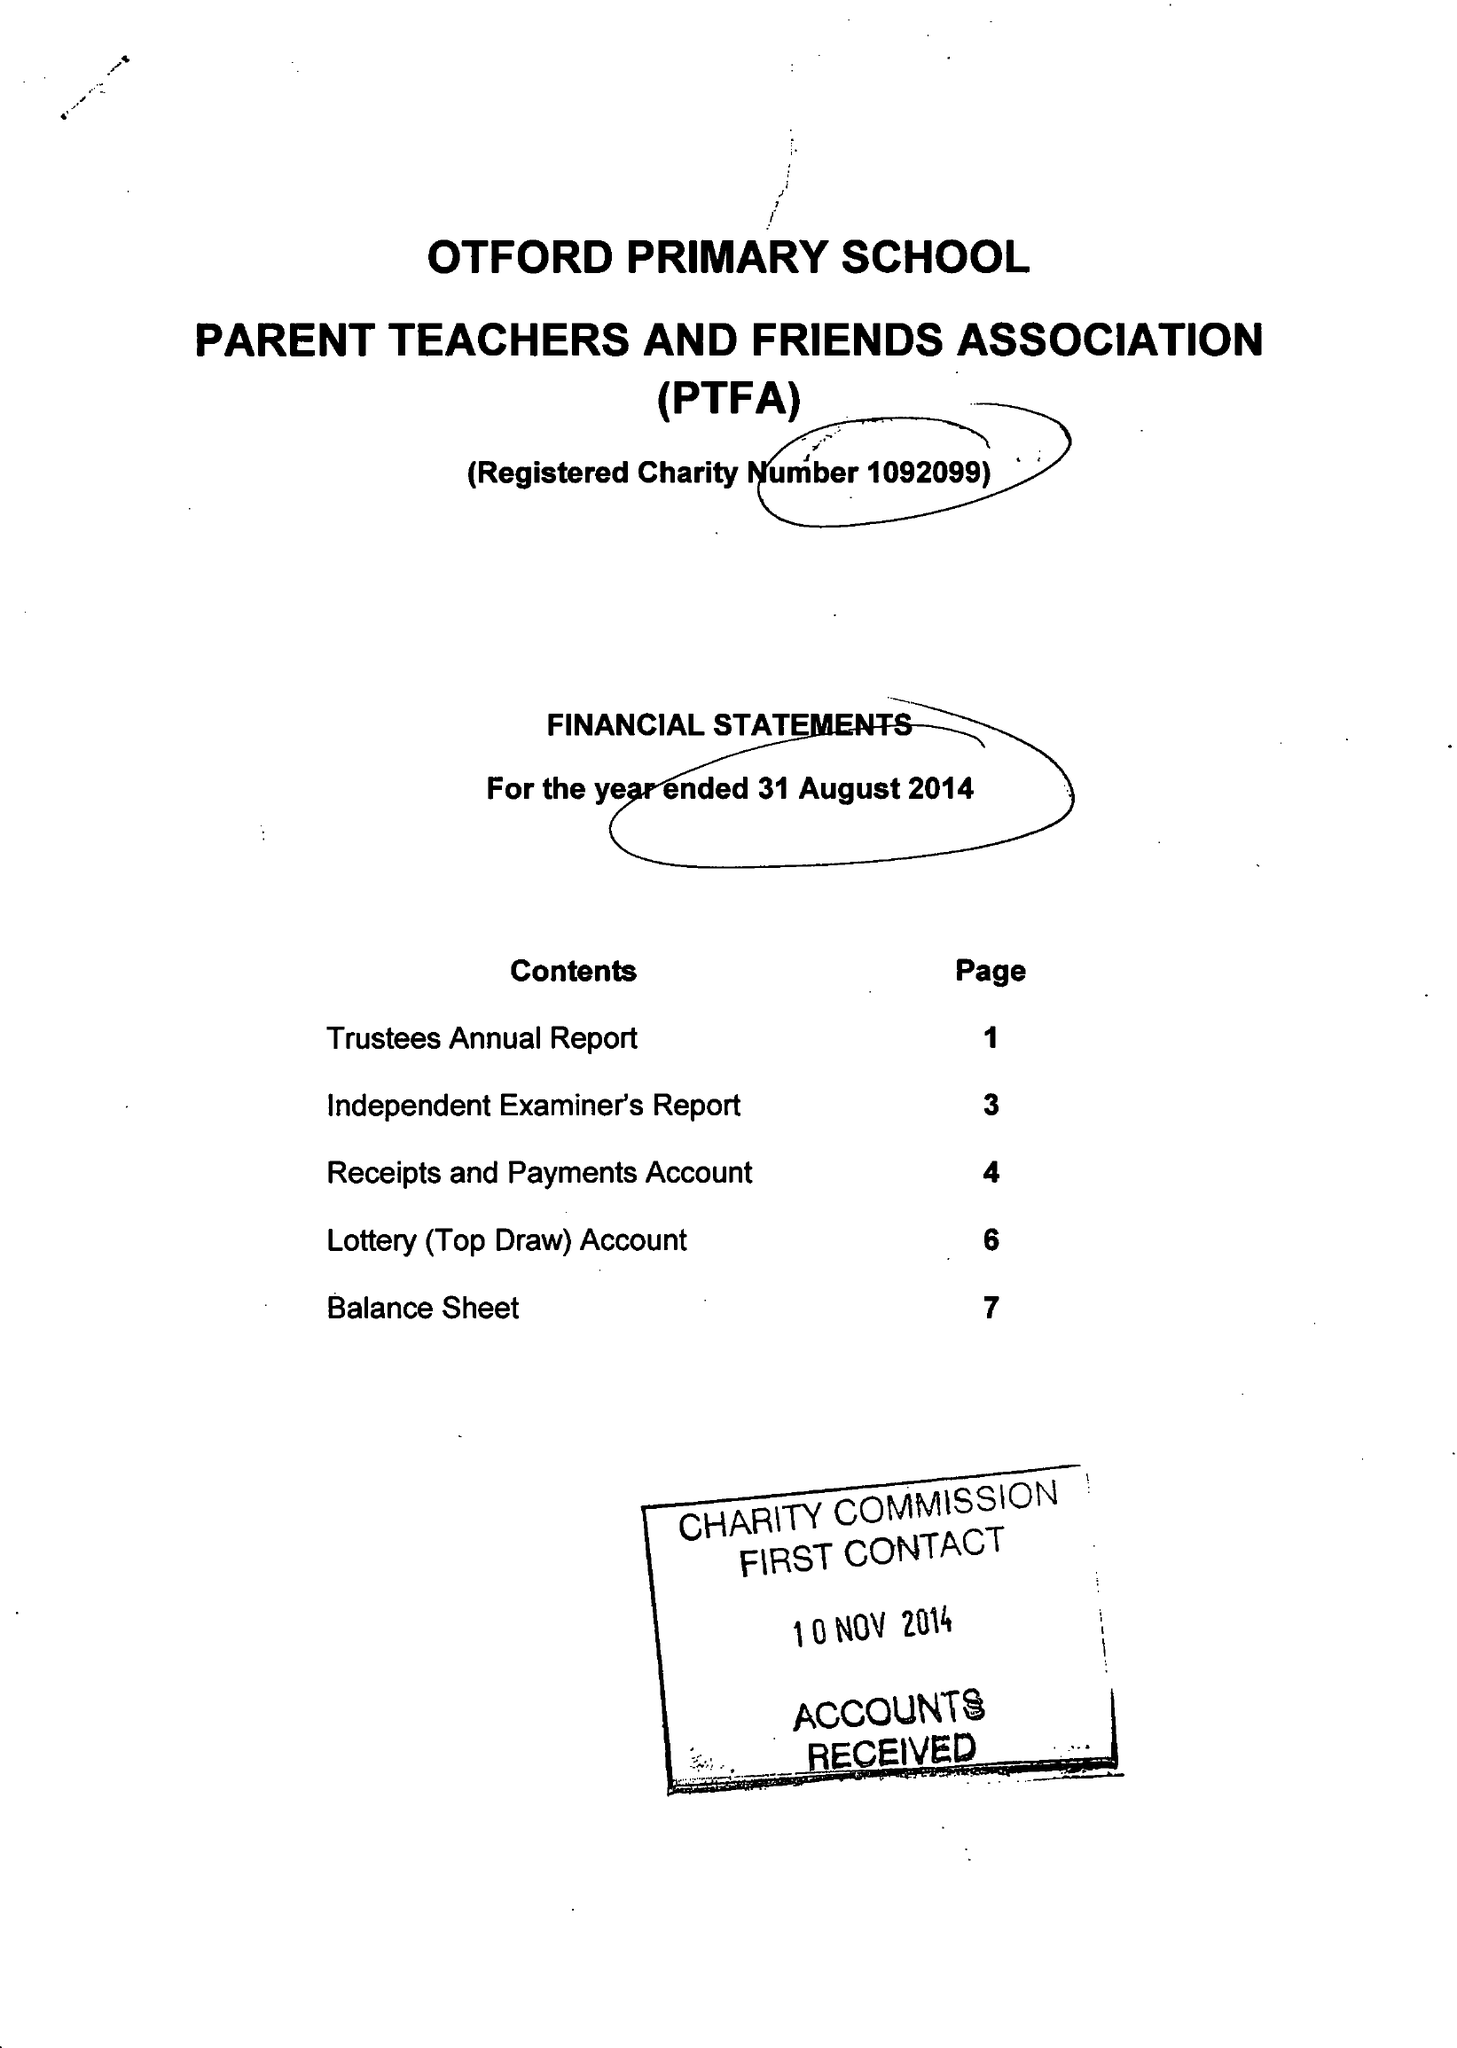What is the value for the report_date?
Answer the question using a single word or phrase. 2014-08-31 